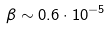<formula> <loc_0><loc_0><loc_500><loc_500>\beta \sim 0 . 6 \cdot 1 0 ^ { - 5 }</formula> 